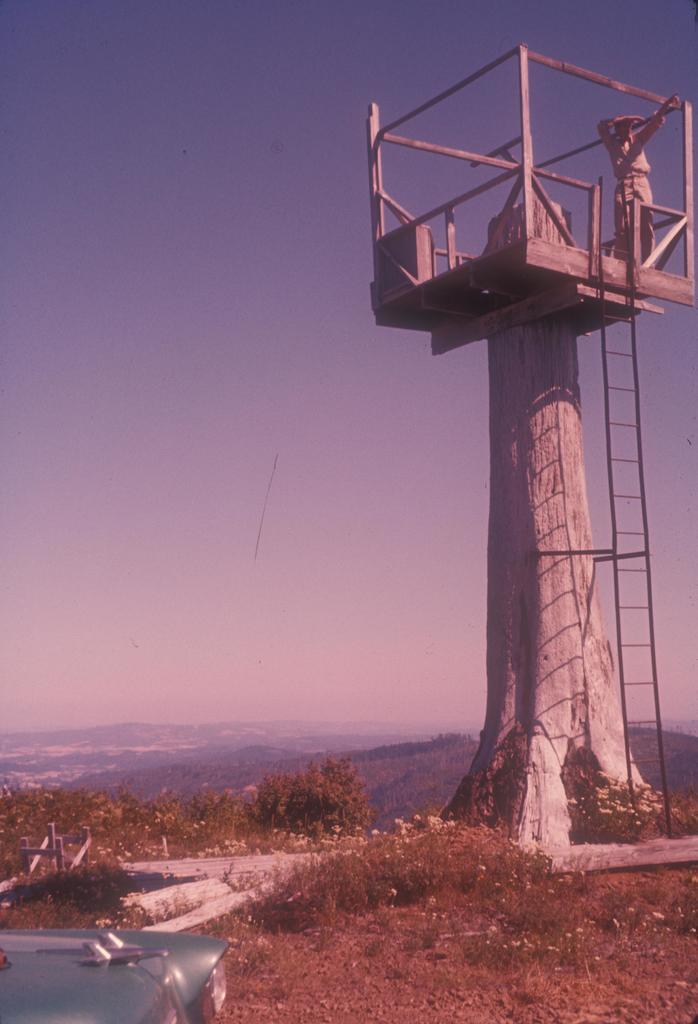Please provide a concise description of this image. In this image I can see the tower and I can also see the person standing, background I can see few trees in green color and the sky is in blue and white color. 